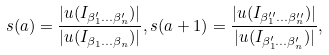Convert formula to latex. <formula><loc_0><loc_0><loc_500><loc_500>s ( a ) = \frac { | u ( I _ { \beta _ { 1 } ^ { \prime } \dots \beta _ { n } ^ { \prime } } ) | } { | u ( I _ { \beta _ { 1 } \dots \beta _ { n } } ) | } , s ( a + 1 ) = \frac { | u ( I _ { \beta _ { 1 } ^ { \prime \prime } \dots \beta _ { n } ^ { \prime \prime } } ) | } { | u ( I _ { \beta _ { 1 } ^ { \prime } \dots \beta _ { n } ^ { \prime } } ) | } ,</formula> 